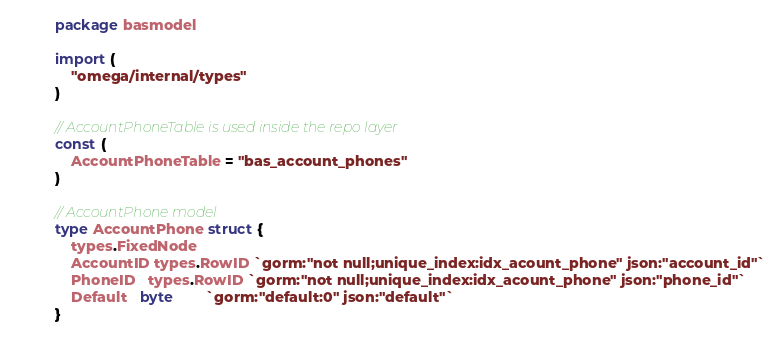<code> <loc_0><loc_0><loc_500><loc_500><_Go_>package basmodel

import (
	"omega/internal/types"
)

// AccountPhoneTable is used inside the repo layer
const (
	AccountPhoneTable = "bas_account_phones"
)

// AccountPhone model
type AccountPhone struct {
	types.FixedNode
	AccountID types.RowID `gorm:"not null;unique_index:idx_acount_phone" json:"account_id"`
	PhoneID   types.RowID `gorm:"not null;unique_index:idx_acount_phone" json:"phone_id"`
	Default   byte        `gorm:"default:0" json:"default"`
}
</code> 